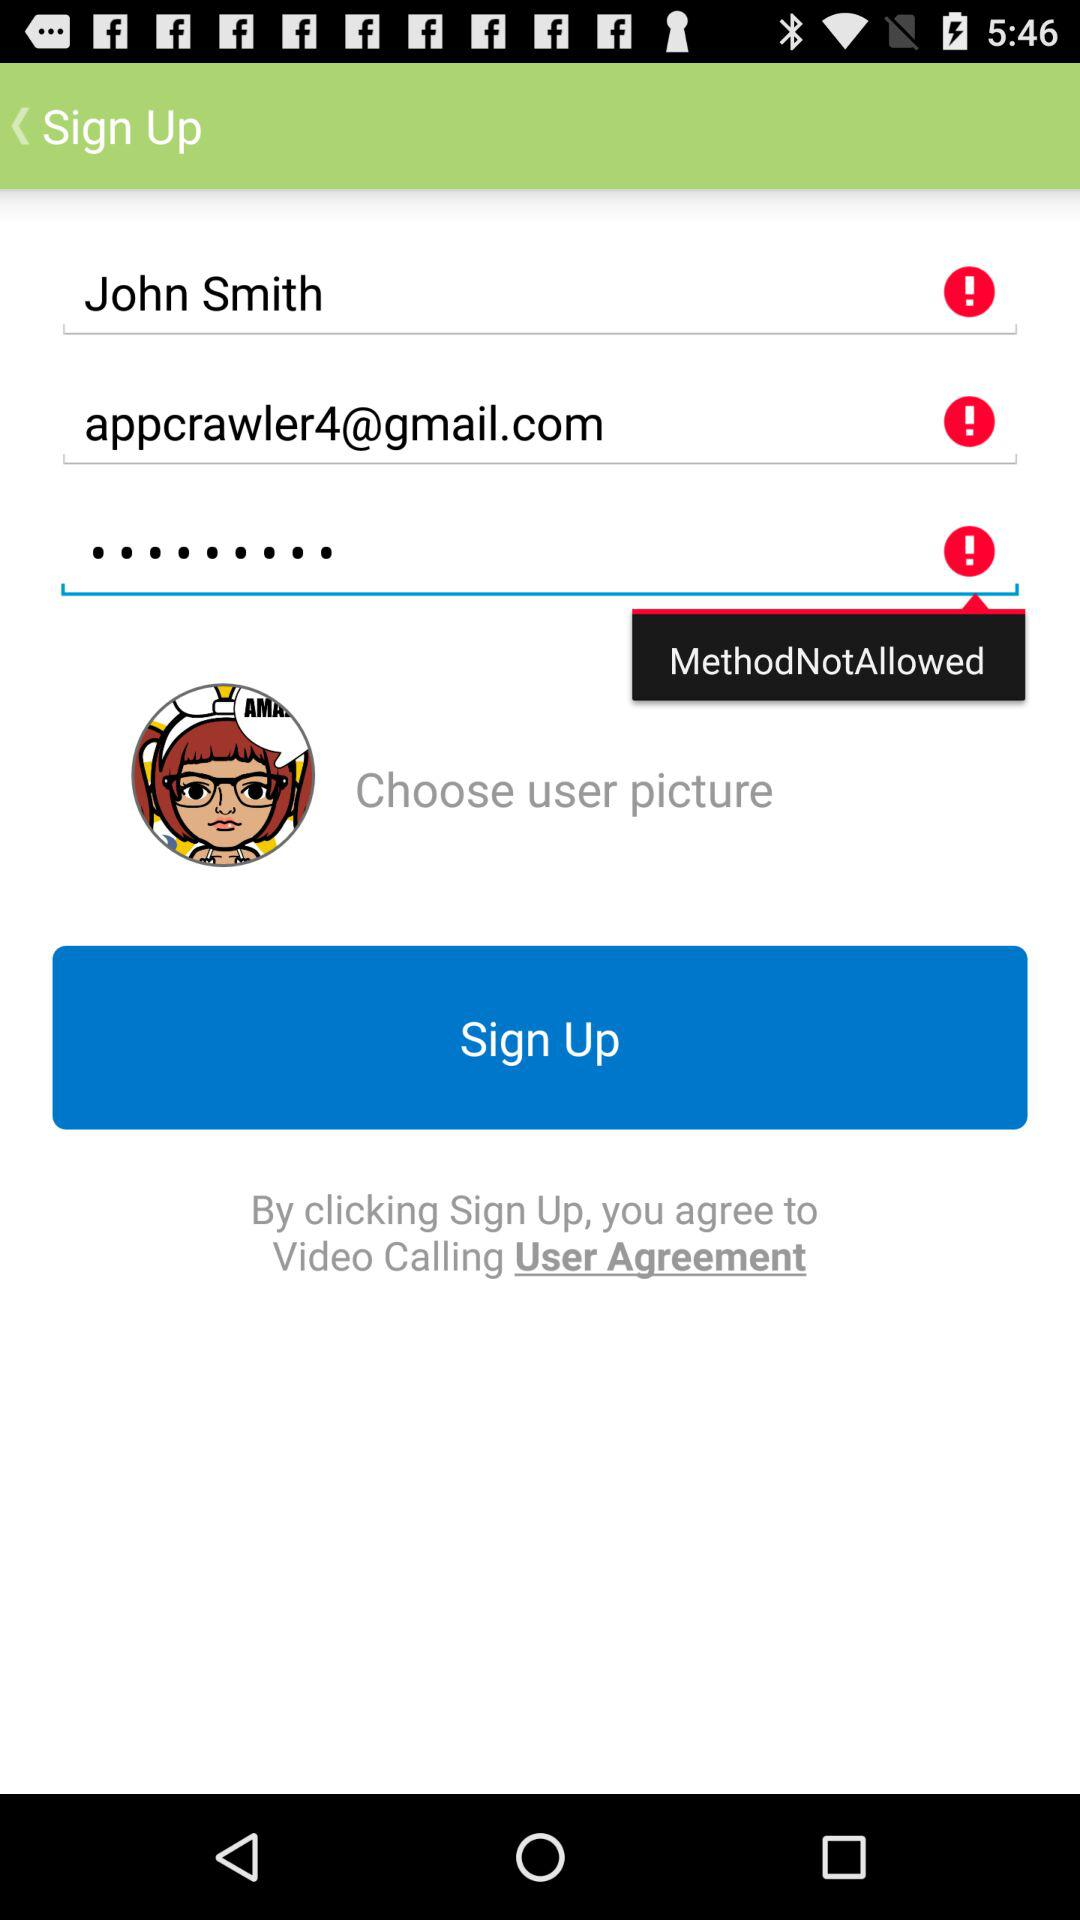How many fields are required to sign up?
Answer the question using a single word or phrase. 3 